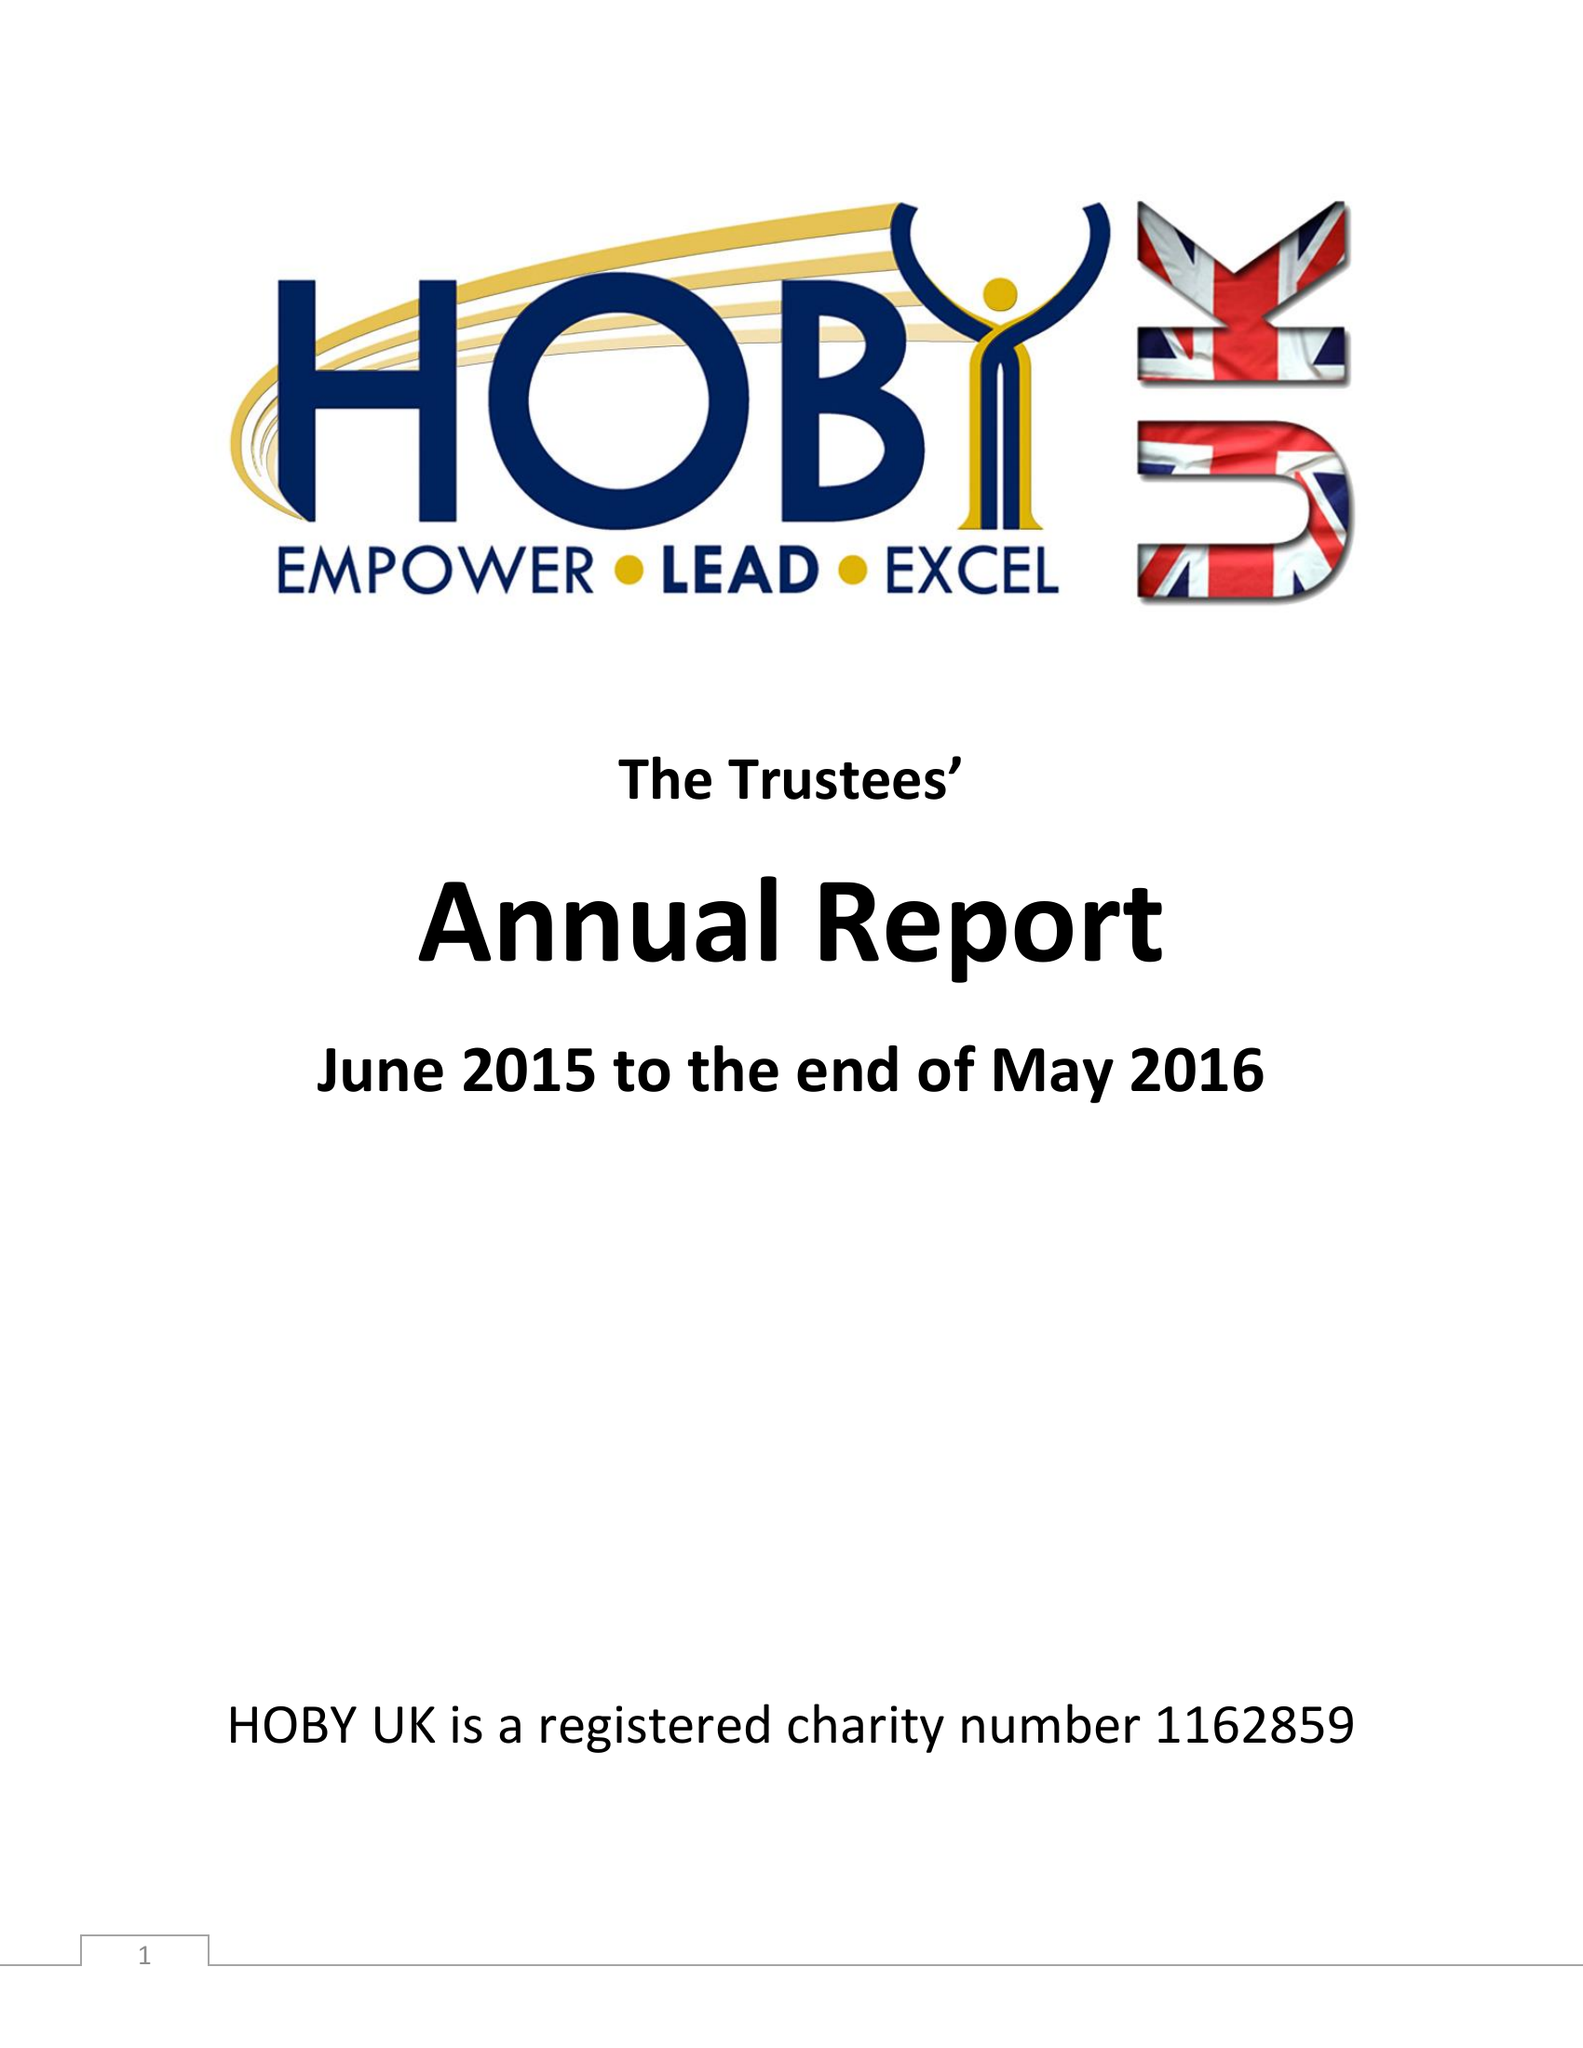What is the value for the address__post_town?
Answer the question using a single word or phrase. LIVERPOOL 